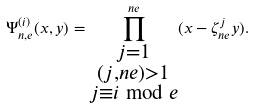Convert formula to latex. <formula><loc_0><loc_0><loc_500><loc_500>\Psi _ { n , e } ^ { ( i ) } ( x , y ) = \prod ^ { n e } _ { \substack { j = 1 \\ ( j , n e ) > 1 \\ j \equiv i \bmod e } } ( x - \zeta ^ { j } _ { n e } y ) .</formula> 